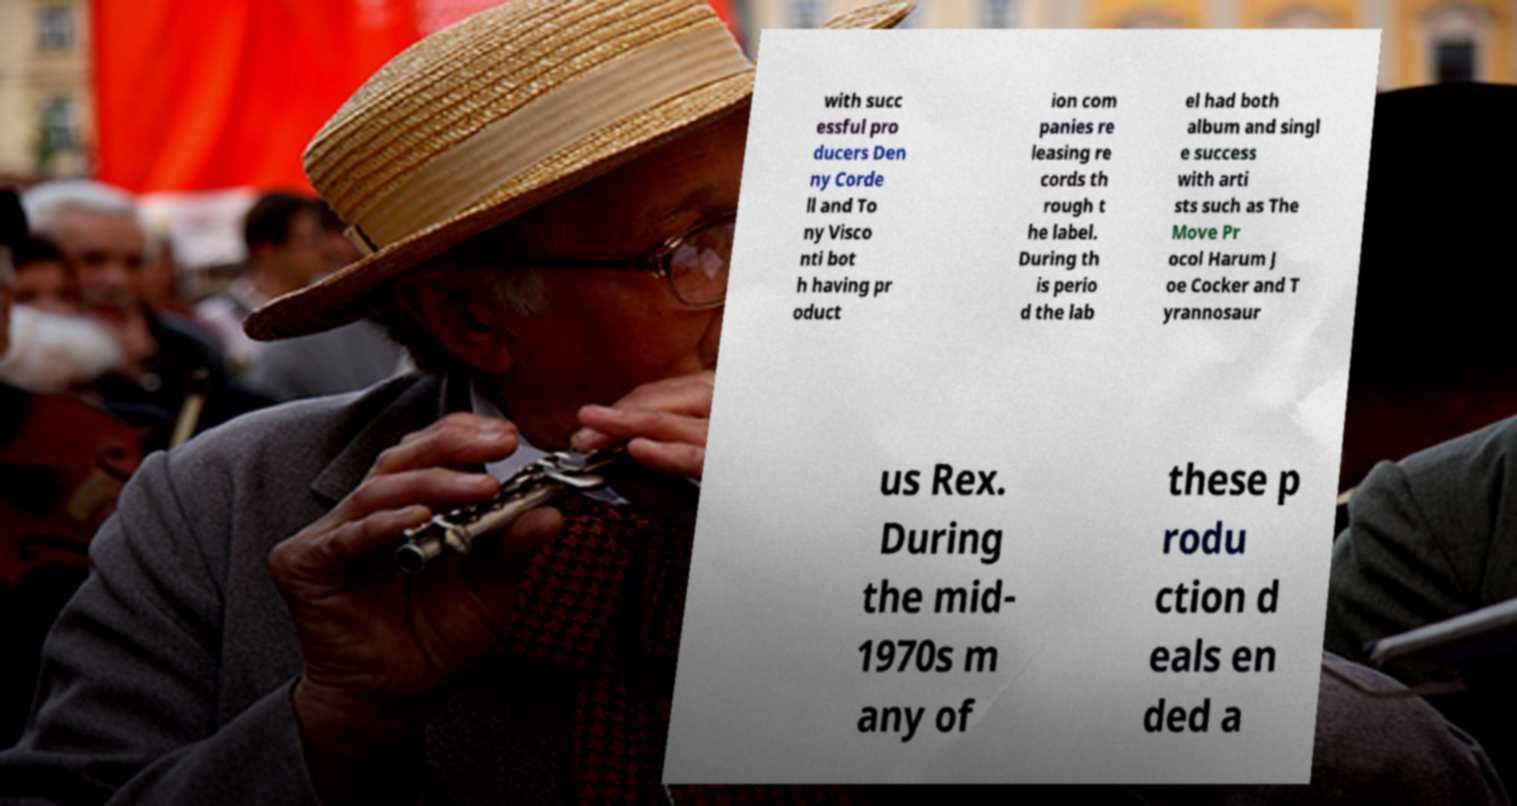What messages or text are displayed in this image? I need them in a readable, typed format. with succ essful pro ducers Den ny Corde ll and To ny Visco nti bot h having pr oduct ion com panies re leasing re cords th rough t he label. During th is perio d the lab el had both album and singl e success with arti sts such as The Move Pr ocol Harum J oe Cocker and T yrannosaur us Rex. During the mid- 1970s m any of these p rodu ction d eals en ded a 